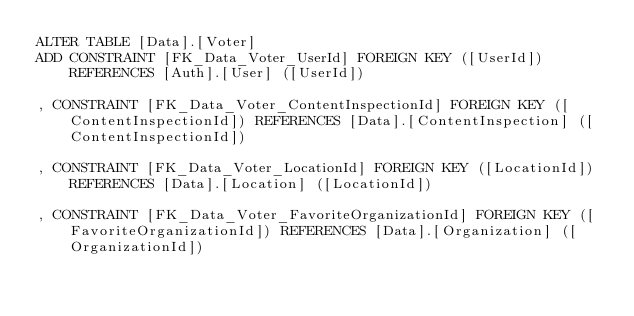Convert code to text. <code><loc_0><loc_0><loc_500><loc_500><_SQL_>ALTER TABLE [Data].[Voter]
ADD	CONSTRAINT [FK_Data_Voter_UserId] FOREIGN KEY ([UserId]) REFERENCES [Auth].[User] ([UserId])

,	CONSTRAINT [FK_Data_Voter_ContentInspectionId] FOREIGN KEY ([ContentInspectionId]) REFERENCES [Data].[ContentInspection] ([ContentInspectionId])

,	CONSTRAINT [FK_Data_Voter_LocationId] FOREIGN KEY ([LocationId]) REFERENCES [Data].[Location] ([LocationId])

,	CONSTRAINT [FK_Data_Voter_FavoriteOrganizationId] FOREIGN KEY ([FavoriteOrganizationId]) REFERENCES [Data].[Organization] ([OrganizationId])

</code> 